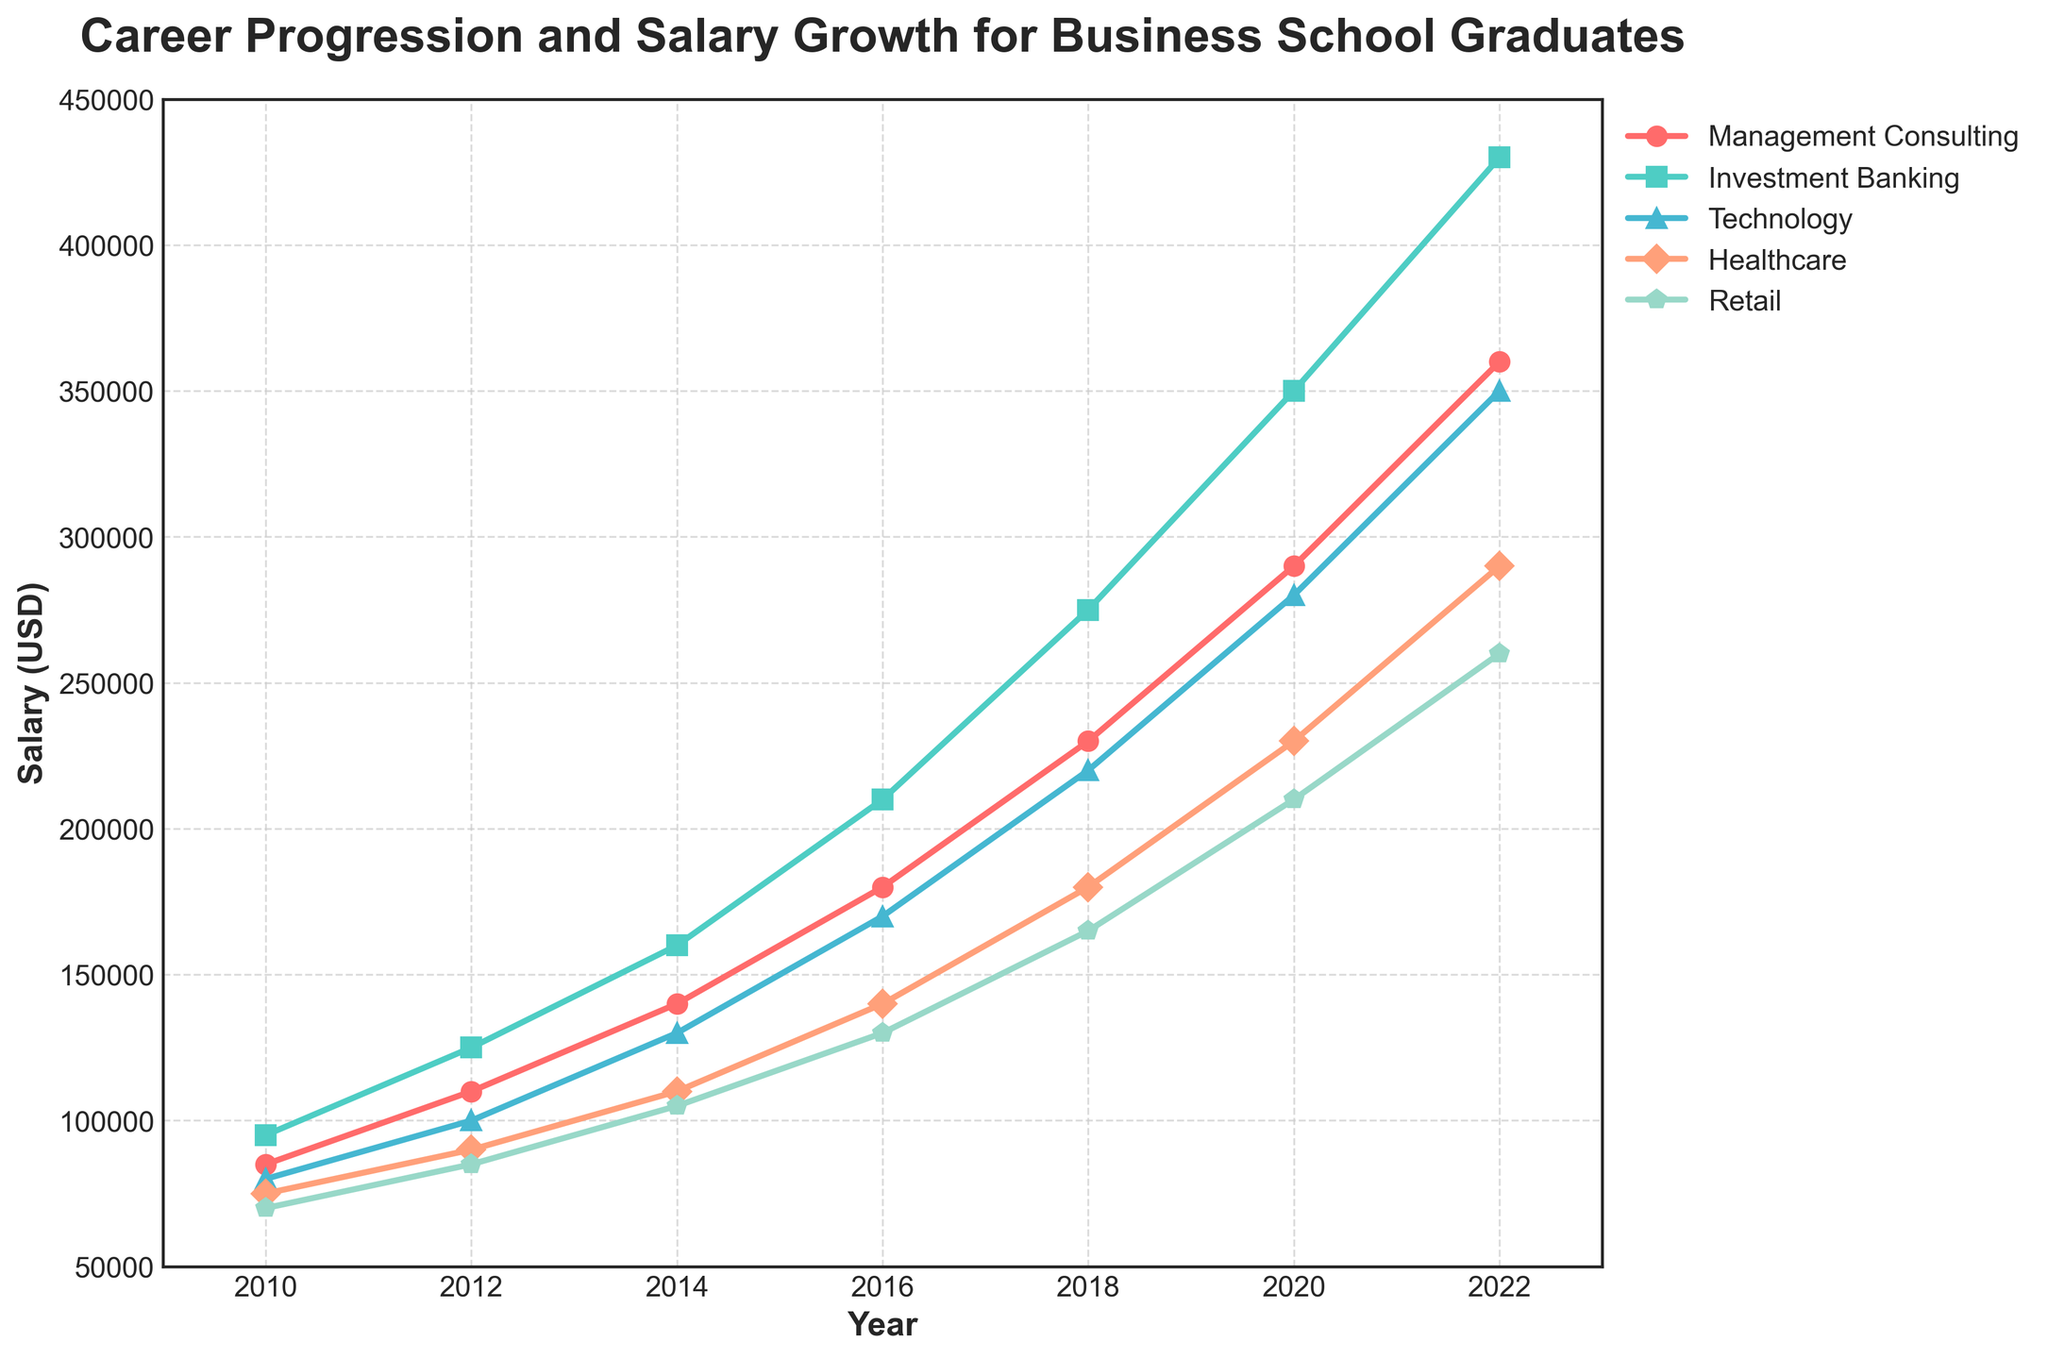What year did the salary for Technology graduates exceed that of Healthcare graduates by at least 40,000 USD? First, find the years and the corresponding salaries for Technology and Healthcare graduates. In 2014, Technology (130,000) minus Healthcare (110,000) equals 20,000, less than 40,000. In 2016, Technology (170,000) minus Healthcare (140,000) equals 30,000, still less than 40,000. In 2018, Technology (220,000) minus Healthcare (180,000) equals 40,000. Thus, 2018 is the first year this condition is met.
Answer: 2018 In 2020, which industry had the highest salary, and what was the amount? Refer to the 2020 data point across all industries and identify the highest value. Investment Banking shows the highest salary at 350,000 USD.
Answer: Investment Banking, 350,000 USD Between 2012 and 2022, which industry had the least growth in salary? Calculate the salary growth for each industry by subtracting the 2012 salary from the 2022 salary. Management Consulting: 360,000 - 110,000 = 250,000; Investment Banking: 430,000 - 125,000 = 305,000; Technology: 350,000 - 100,000 = 250,000; Healthcare: 290,000 - 90,000 = 200,000; Retail: 260,000 - 85,000 = 175,000. Retail has the least growth at 175,000 USD.
Answer: Retail Which industry experienced the steepest increase in salary from 2010 to 2022? Determine the increase in salary for each industry from 2010 to 2022. Investment Banking: 430,000 - 95,000 = 335,000; Management Consulting: 360,000 - 85,000 = 275,000; Technology: 350,000 - 80,000 = 270,000; Healthcare: 290,000 - 75,000 = 215,000; Retail: 260,000 - 70,000 = 190,000. Investment Banking has the steepest increase at 335,000 USD.
Answer: Investment Banking By how much did the salary of Management Consulting graduates increase from 2010 to 2016? To find the increase, subtract the 2010 salary from the 2016 salary. Management Consulting: 180,000 - 85,000 = 95,000 USD increase.
Answer: 95,000 USD In which year did Healthcare graduates' salaries first reach 100,000 USD or more? Check the years when Healthcare graduates' salaries meet or exceed 100,000 USD. 2010: 75,000; 2012: 90,000; 2014: 110,000. The first year is 2014.
Answer: 2014 Compare the salary trajectory of Retail graduates to Technology graduates. Which industry shows a steeper slope, and in what period? By examining the plot, Retail has a gradually increasing slope, while Technology displays a sharper rise. Particularly, between 2016 and 2018, Technology’s salary jumps from 170,000 to 220,000 (50,000), whereas Retail increases from 130,000 to 165,000 (35,000). Thus, in this period, Technology shows a steeper slope.
Answer: Technology, from 2016 to 2018 How much more did Investment Banking graduates earn compared to Retail graduates in 2022? Subtract the 2022 salary of Retail graduates from that of Investment Banking graduates. Investment Banking: 430,000; Retail: 260,000. Difference: 430,000 - 260,000 = 170,000 USD.
Answer: 170,000 USD In 2018, which industry had the smallest salary increase from 2016, and what was this increase? Compare the difference between 2016 and 2018 salaries across industries. Management Consulting: 50,000 increase (230,000 - 180,000); Investment Banking: 65,000 increase (275,000 - 210,000); Technology: 50,000 increase (220,000 - 170,000); Healthcare: 40,000 increase (180,000 - 140,000); Retail: 35,000 increase (165,000 - 130,000). Therefore, Retail had the smallest increase of 35,000 USD.
Answer: Retail, 35,000 USD What is the total combined salary of all industries in 2010? Add the 2010 salaries of all industries. Management Consulting: 85,000; Investment Banking: 95,000; Technology: 80,000; Healthcare: 75,000; Retail: 70,000. Total: 85,000 + 95,000 + 80,000 + 75,000 + 70,000 = 405,000 USD.
Answer: 405,000 USD 